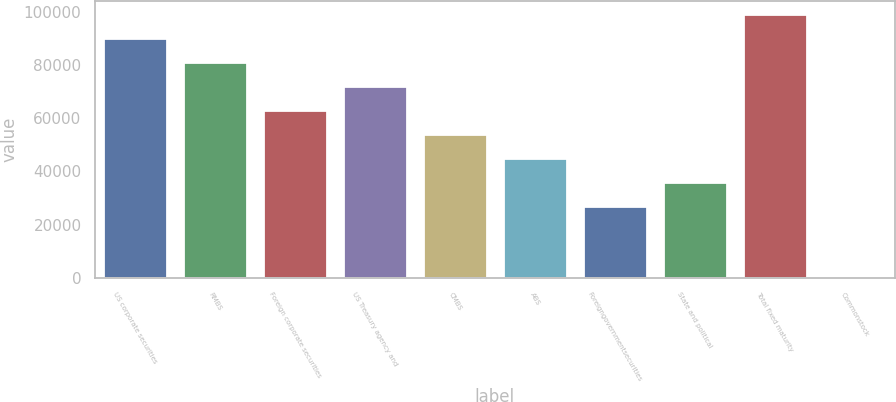Convert chart. <chart><loc_0><loc_0><loc_500><loc_500><bar_chart><fcel>US corporate securities<fcel>RMBS<fcel>Foreign corporate securities<fcel>US Treasury agency and<fcel>CMBS<fcel>ABS<fcel>Foreigngovernmentsecurities<fcel>State and political<fcel>Total fixed maturity<fcel>Commonstock<nl><fcel>90087<fcel>81085.3<fcel>63081.9<fcel>72083.6<fcel>54080.2<fcel>45078.5<fcel>27075.1<fcel>36076.8<fcel>99088.7<fcel>70<nl></chart> 